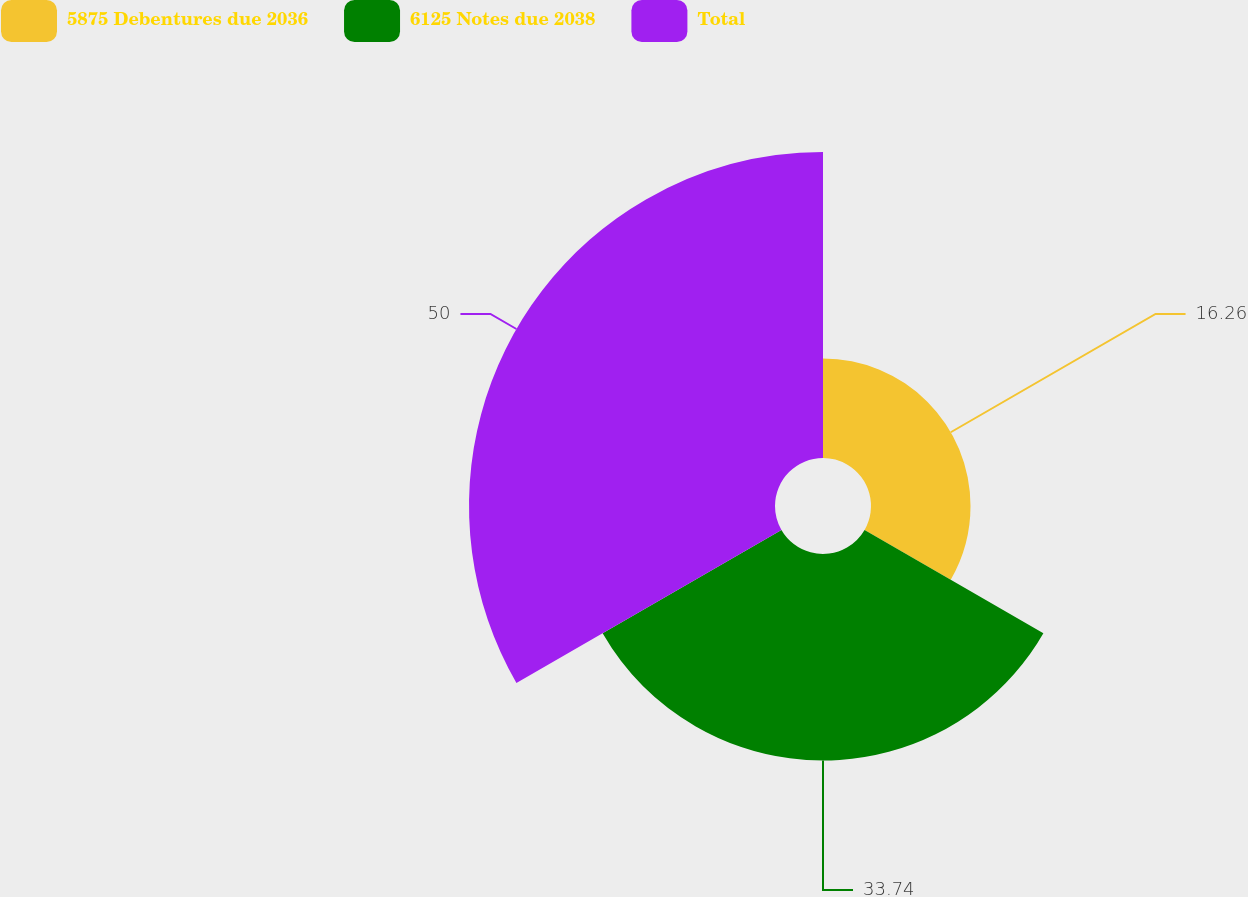Convert chart to OTSL. <chart><loc_0><loc_0><loc_500><loc_500><pie_chart><fcel>5875 Debentures due 2036<fcel>6125 Notes due 2038<fcel>Total<nl><fcel>16.26%<fcel>33.74%<fcel>50.0%<nl></chart> 